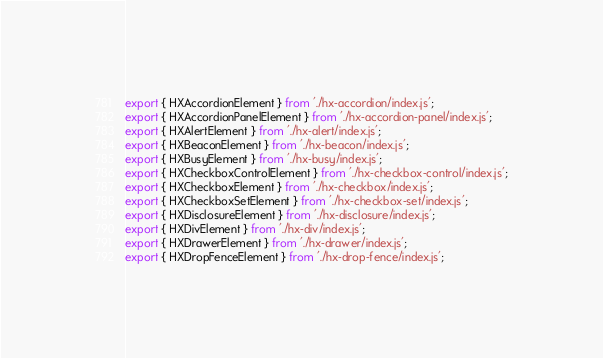<code> <loc_0><loc_0><loc_500><loc_500><_JavaScript_>export { HXAccordionElement } from './hx-accordion/index.js';
export { HXAccordionPanelElement } from './hx-accordion-panel/index.js';
export { HXAlertElement } from './hx-alert/index.js';
export { HXBeaconElement } from './hx-beacon/index.js';
export { HXBusyElement } from './hx-busy/index.js';
export { HXCheckboxControlElement } from './hx-checkbox-control/index.js';
export { HXCheckboxElement } from './hx-checkbox/index.js';
export { HXCheckboxSetElement } from './hx-checkbox-set/index.js';
export { HXDisclosureElement } from './hx-disclosure/index.js';
export { HXDivElement } from './hx-div/index.js';
export { HXDrawerElement } from './hx-drawer/index.js';
export { HXDropFenceElement } from './hx-drop-fence/index.js';</code> 